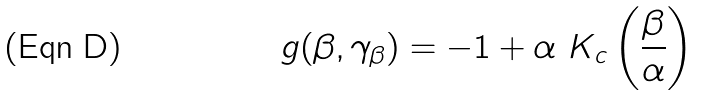Convert formula to latex. <formula><loc_0><loc_0><loc_500><loc_500>g ( \beta , \gamma _ { \beta } ) = - 1 + \alpha \ K _ { c } \left ( \frac { \beta } { \alpha } \right )</formula> 